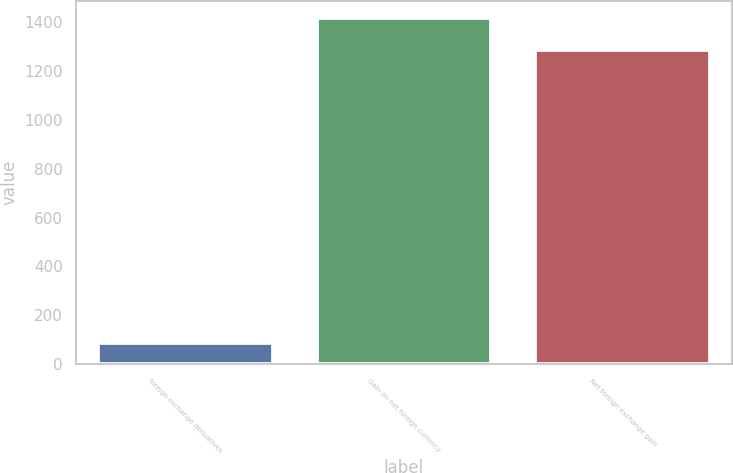<chart> <loc_0><loc_0><loc_500><loc_500><bar_chart><fcel>foreign exchange derivatives<fcel>Gain on net foreign currency<fcel>Net foreign exchange gain<nl><fcel>87<fcel>1414.6<fcel>1286<nl></chart> 